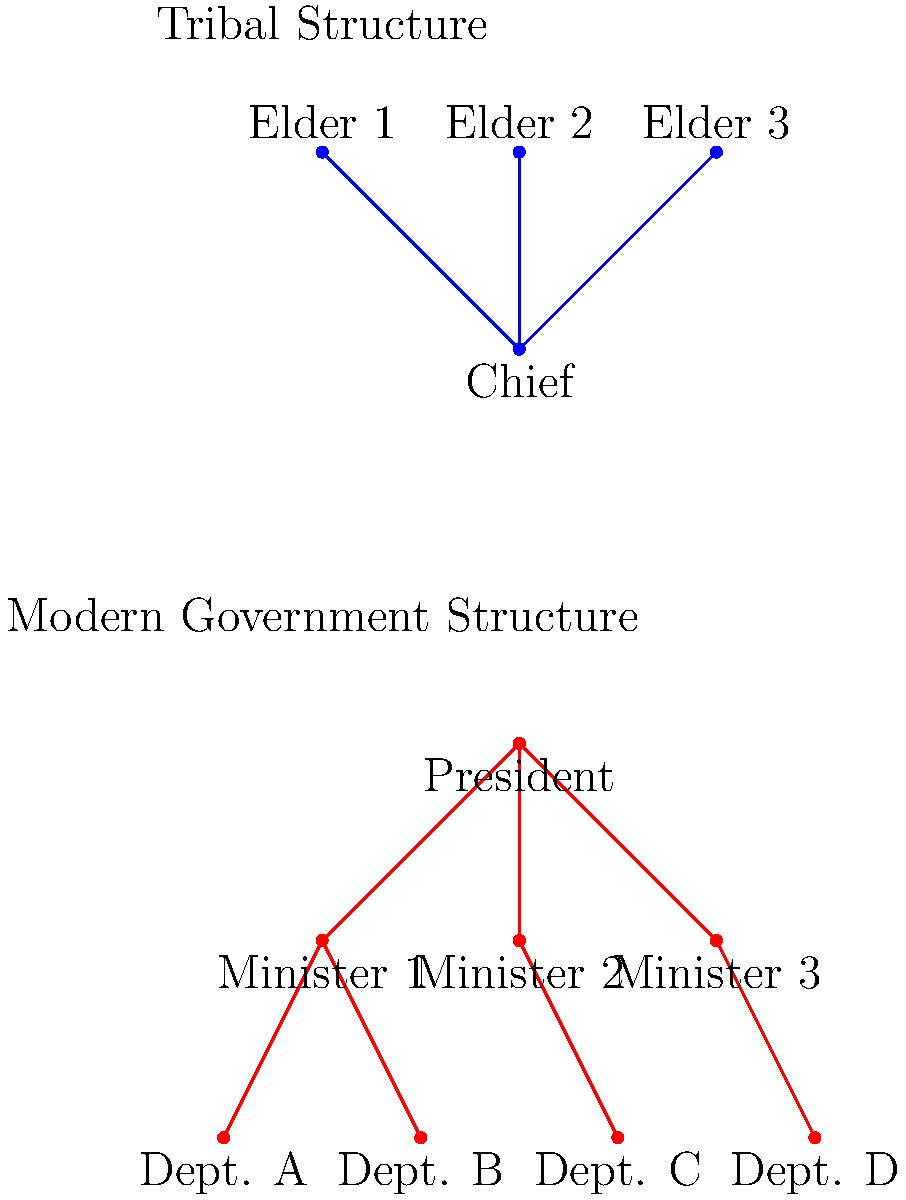Based on the organizational charts provided, what is the key difference in the hierarchical structure between the tribal system and the modern governmental system? To answer this question, let's analyze the two organizational charts step-by-step:

1. Tribal Structure:
   - At the top, there is a single Chief.
   - Directly below the Chief, there are three Elders.
   - The structure is flat, with only two levels.

2. Modern Government Structure:
   - At the top, there is a President.
   - Below the President, there are three Ministers.
   - Below the Ministers, there are Departments.
   - The structure has three distinct levels.

3. Key Differences:
   a) Levels of hierarchy:
      - Tribal: 2 levels
      - Modern Government: 3 levels

   b) Distribution of authority:
      - Tribal: Authority is concentrated among the Chief and Elders.
      - Modern Government: Authority is distributed across multiple levels.

4. The main structural difference:
   The modern governmental system has an additional layer of hierarchy (Departments) between the top leadership and the base, creating a more complex and potentially specialized structure.

Therefore, the key difference in the hierarchical structure is the presence of an additional layer in the modern governmental system, which creates a more complex and potentially more specialized organizational structure compared to the simpler, flatter tribal system.
Answer: Additional hierarchical layer in modern government 